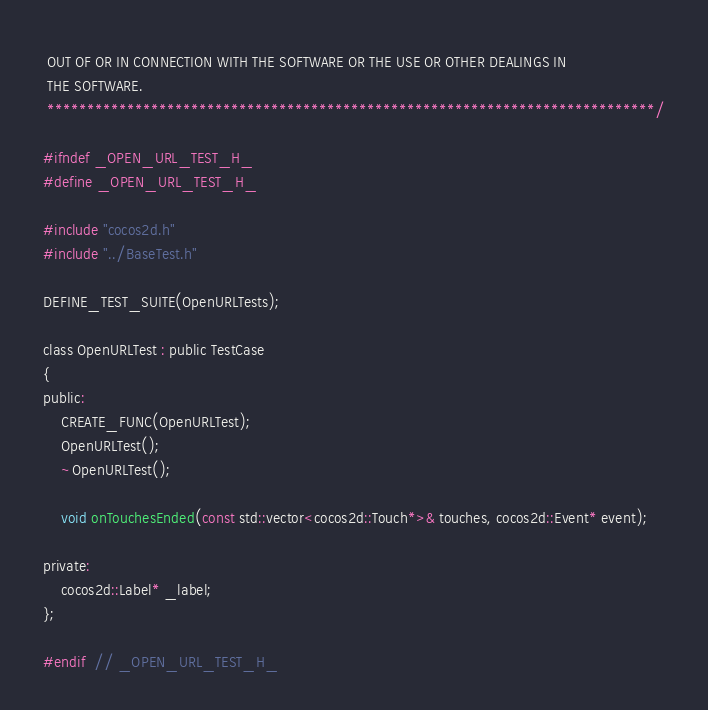Convert code to text. <code><loc_0><loc_0><loc_500><loc_500><_C_> OUT OF OR IN CONNECTION WITH THE SOFTWARE OR THE USE OR OTHER DEALINGS IN
 THE SOFTWARE.
 ****************************************************************************/

#ifndef _OPEN_URL_TEST_H_
#define _OPEN_URL_TEST_H_

#include "cocos2d.h"
#include "../BaseTest.h"

DEFINE_TEST_SUITE(OpenURLTests);

class OpenURLTest : public TestCase
{
public:
    CREATE_FUNC(OpenURLTest);
    OpenURLTest();
    ~OpenURLTest();

    void onTouchesEnded(const std::vector<cocos2d::Touch*>& touches, cocos2d::Event* event);

private:
    cocos2d::Label* _label;
};

#endif  // _OPEN_URL_TEST_H_
</code> 